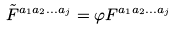Convert formula to latex. <formula><loc_0><loc_0><loc_500><loc_500>\tilde { F } ^ { a _ { 1 } a _ { 2 } \dots a _ { j } } = \varphi F ^ { a _ { 1 } a _ { 2 } \dots a _ { j } }</formula> 